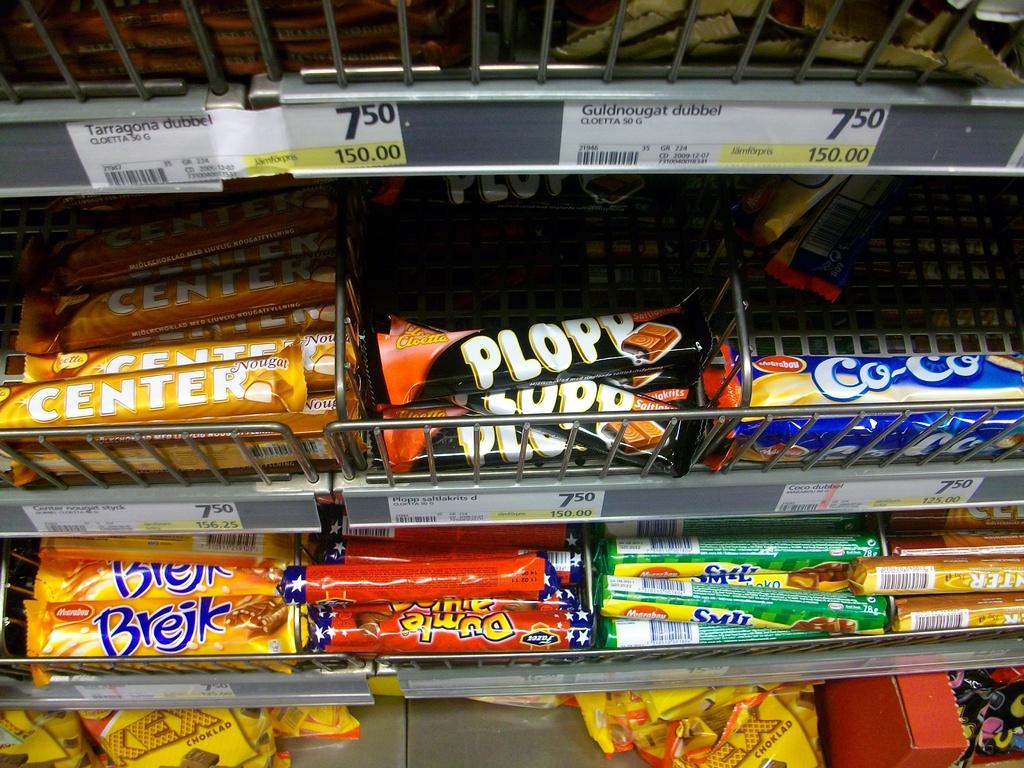What is the cost of the products?
Offer a terse response. 7.50. 